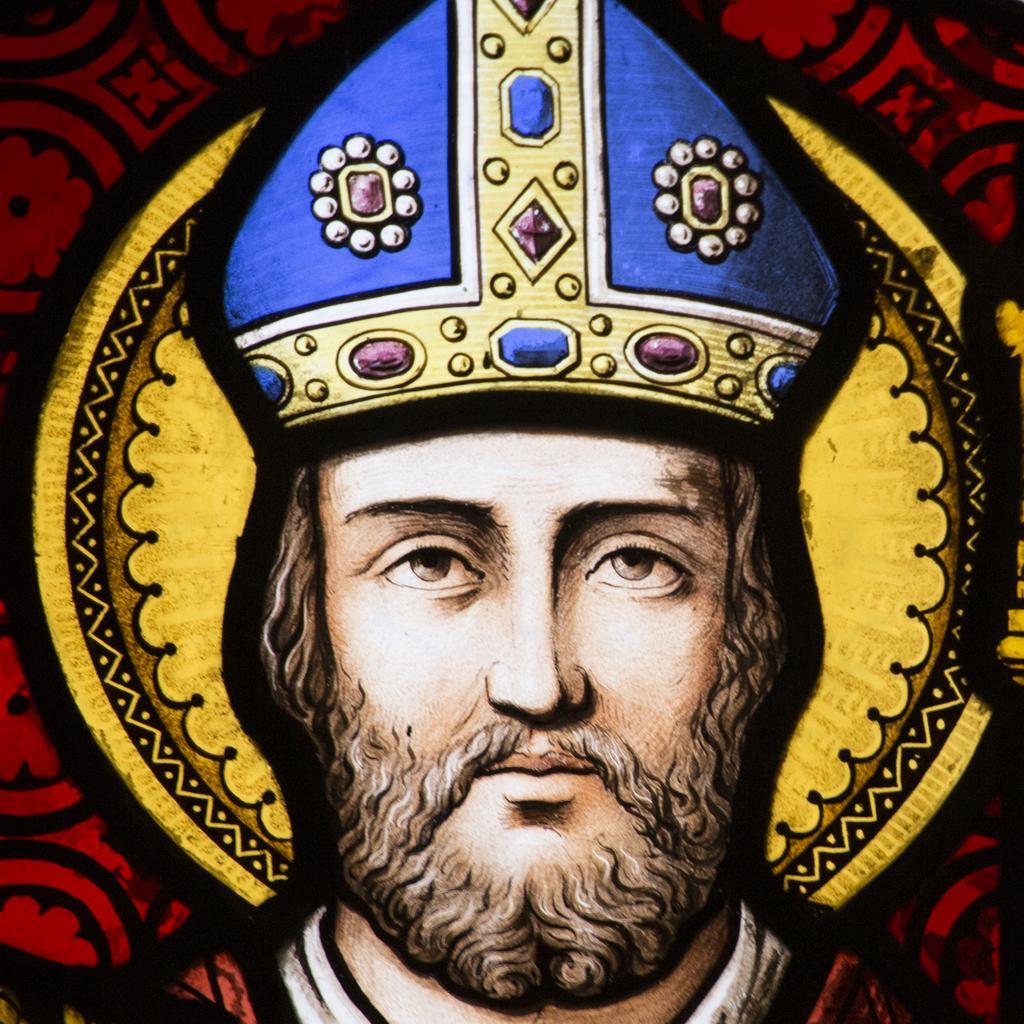How would you summarize this image in a sentence or two? In this image there is a painting of a man who is wearing the crown. In the background there is a red color design. In the ground there are beads and pearls. The man is having a beard. 